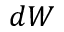<formula> <loc_0><loc_0><loc_500><loc_500>d W</formula> 